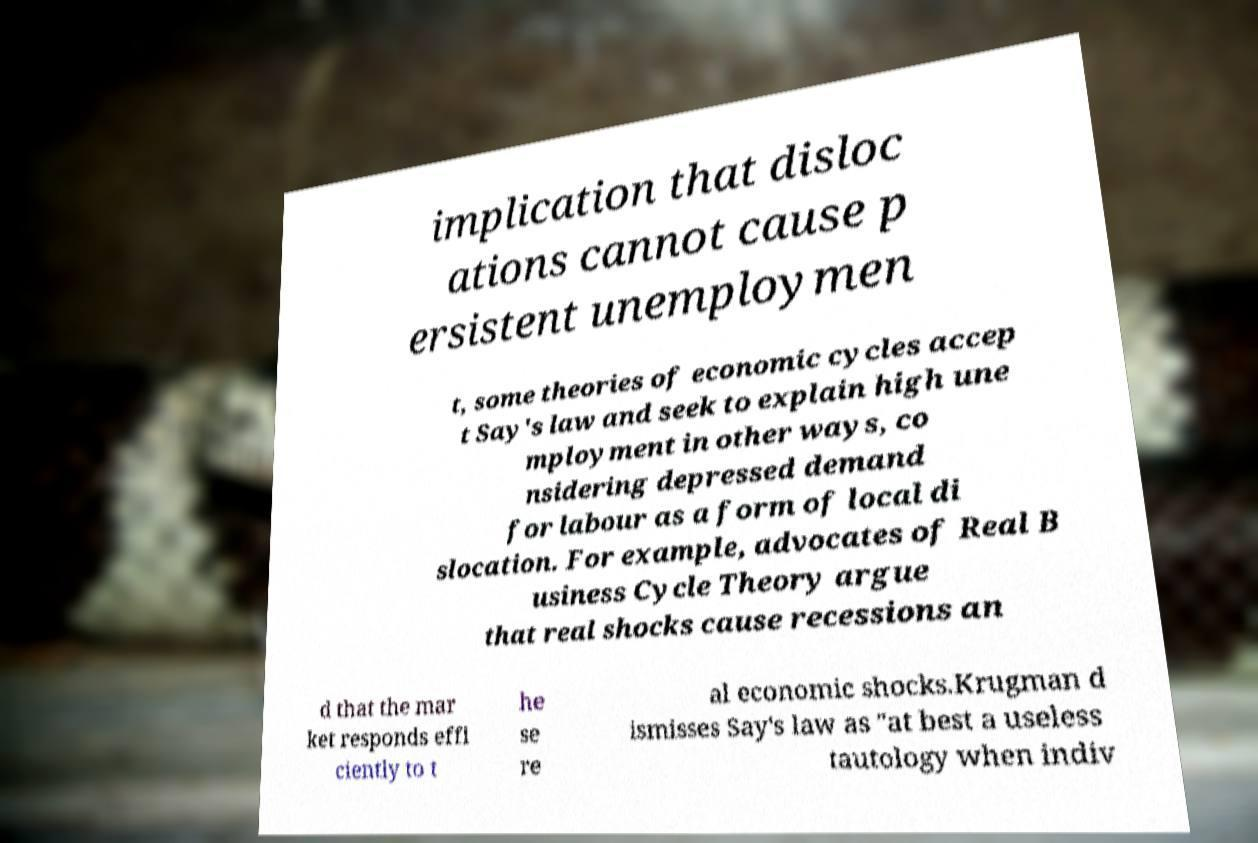For documentation purposes, I need the text within this image transcribed. Could you provide that? implication that disloc ations cannot cause p ersistent unemploymen t, some theories of economic cycles accep t Say's law and seek to explain high une mployment in other ways, co nsidering depressed demand for labour as a form of local di slocation. For example, advocates of Real B usiness Cycle Theory argue that real shocks cause recessions an d that the mar ket responds effi ciently to t he se re al economic shocks.Krugman d ismisses Say's law as "at best a useless tautology when indiv 